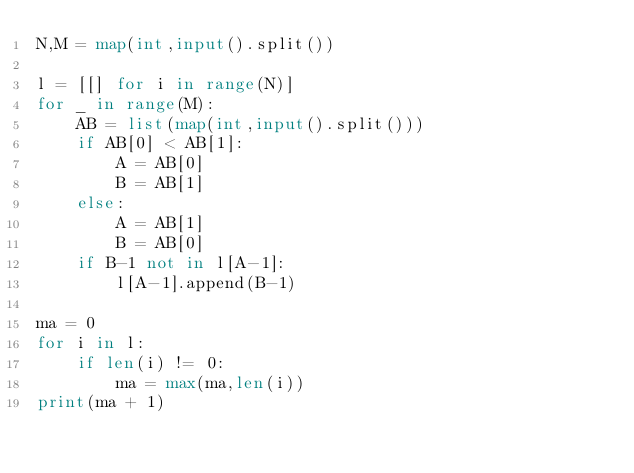Convert code to text. <code><loc_0><loc_0><loc_500><loc_500><_Python_>N,M = map(int,input().split())

l = [[] for i in range(N)]
for _ in range(M):
    AB = list(map(int,input().split()))
    if AB[0] < AB[1]:
        A = AB[0]
        B = AB[1]
    else:
        A = AB[1]
        B = AB[0]
    if B-1 not in l[A-1]:
        l[A-1].append(B-1)

ma = 0
for i in l:
    if len(i) != 0:
        ma = max(ma,len(i))
print(ma + 1)</code> 